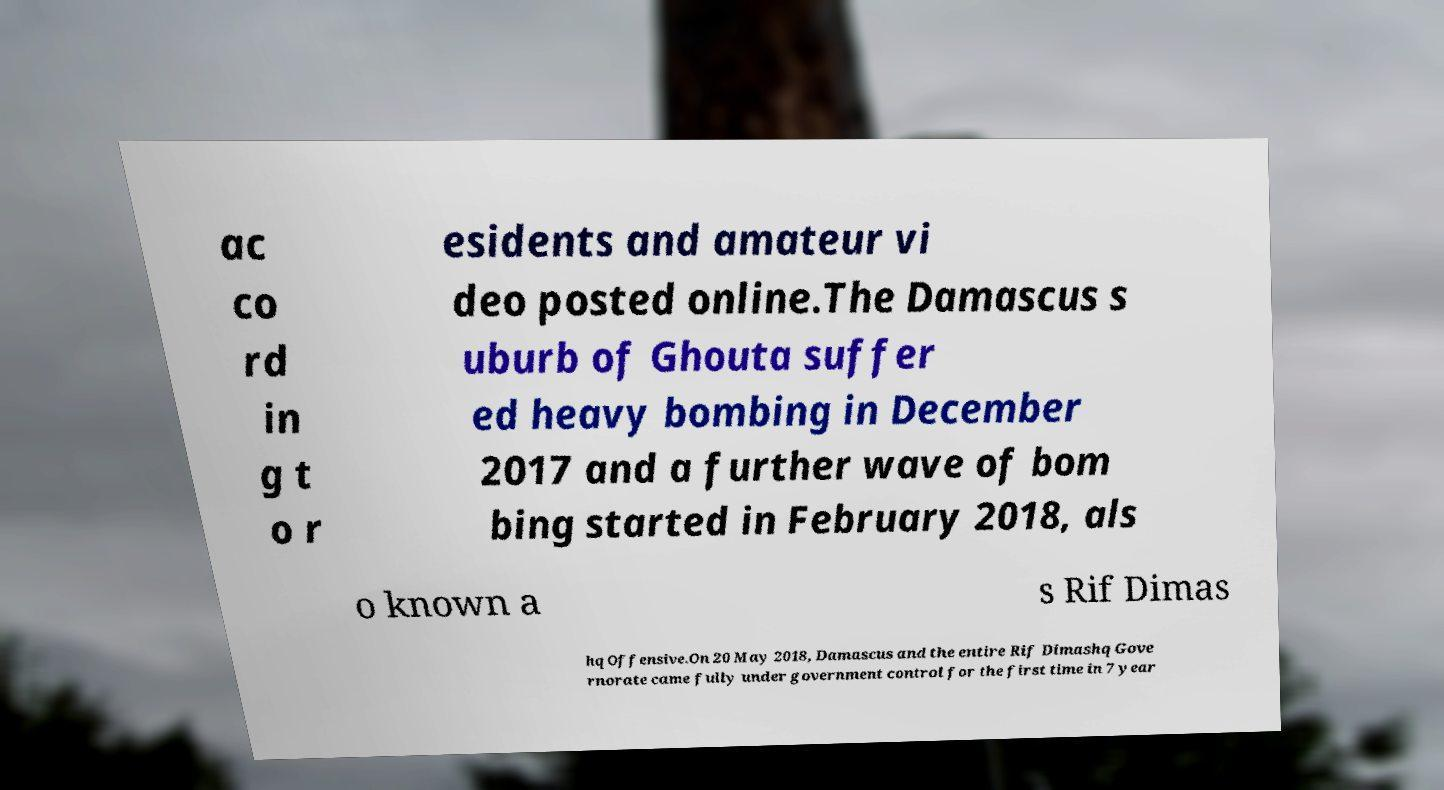Can you accurately transcribe the text from the provided image for me? ac co rd in g t o r esidents and amateur vi deo posted online.The Damascus s uburb of Ghouta suffer ed heavy bombing in December 2017 and a further wave of bom bing started in February 2018, als o known a s Rif Dimas hq Offensive.On 20 May 2018, Damascus and the entire Rif Dimashq Gove rnorate came fully under government control for the first time in 7 year 